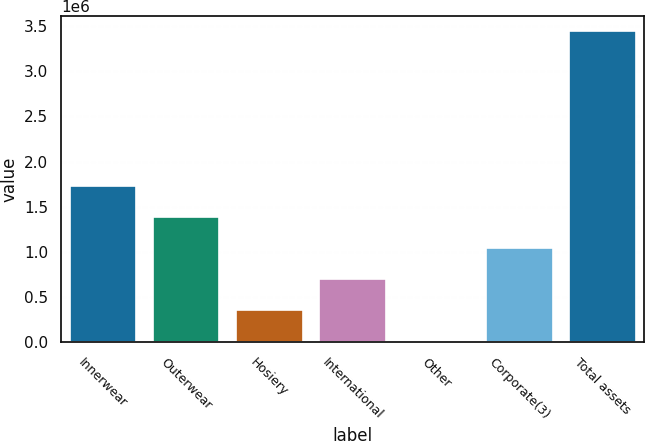Convert chart to OTSL. <chart><loc_0><loc_0><loc_500><loc_500><bar_chart><fcel>Innerwear<fcel>Outerwear<fcel>Hosiery<fcel>International<fcel>Other<fcel>Corporate(3)<fcel>Total assets<nl><fcel>1.72814e+06<fcel>1.38588e+06<fcel>359075<fcel>701342<fcel>16807<fcel>1.04361e+06<fcel>3.43948e+06<nl></chart> 